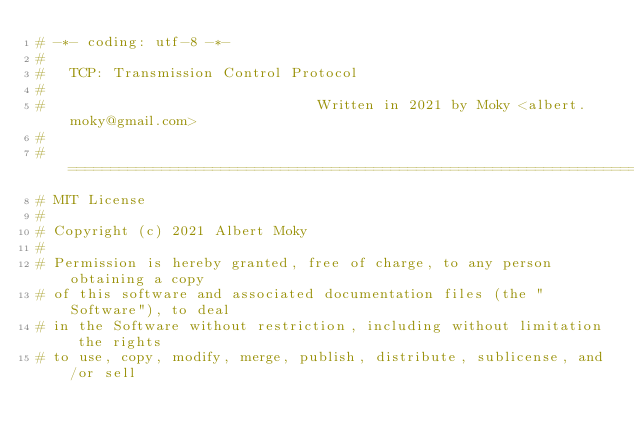<code> <loc_0><loc_0><loc_500><loc_500><_Python_># -*- coding: utf-8 -*-
#
#   TCP: Transmission Control Protocol
#
#                                Written in 2021 by Moky <albert.moky@gmail.com>
#
# ==============================================================================
# MIT License
#
# Copyright (c) 2021 Albert Moky
#
# Permission is hereby granted, free of charge, to any person obtaining a copy
# of this software and associated documentation files (the "Software"), to deal
# in the Software without restriction, including without limitation the rights
# to use, copy, modify, merge, publish, distribute, sublicense, and/or sell</code> 